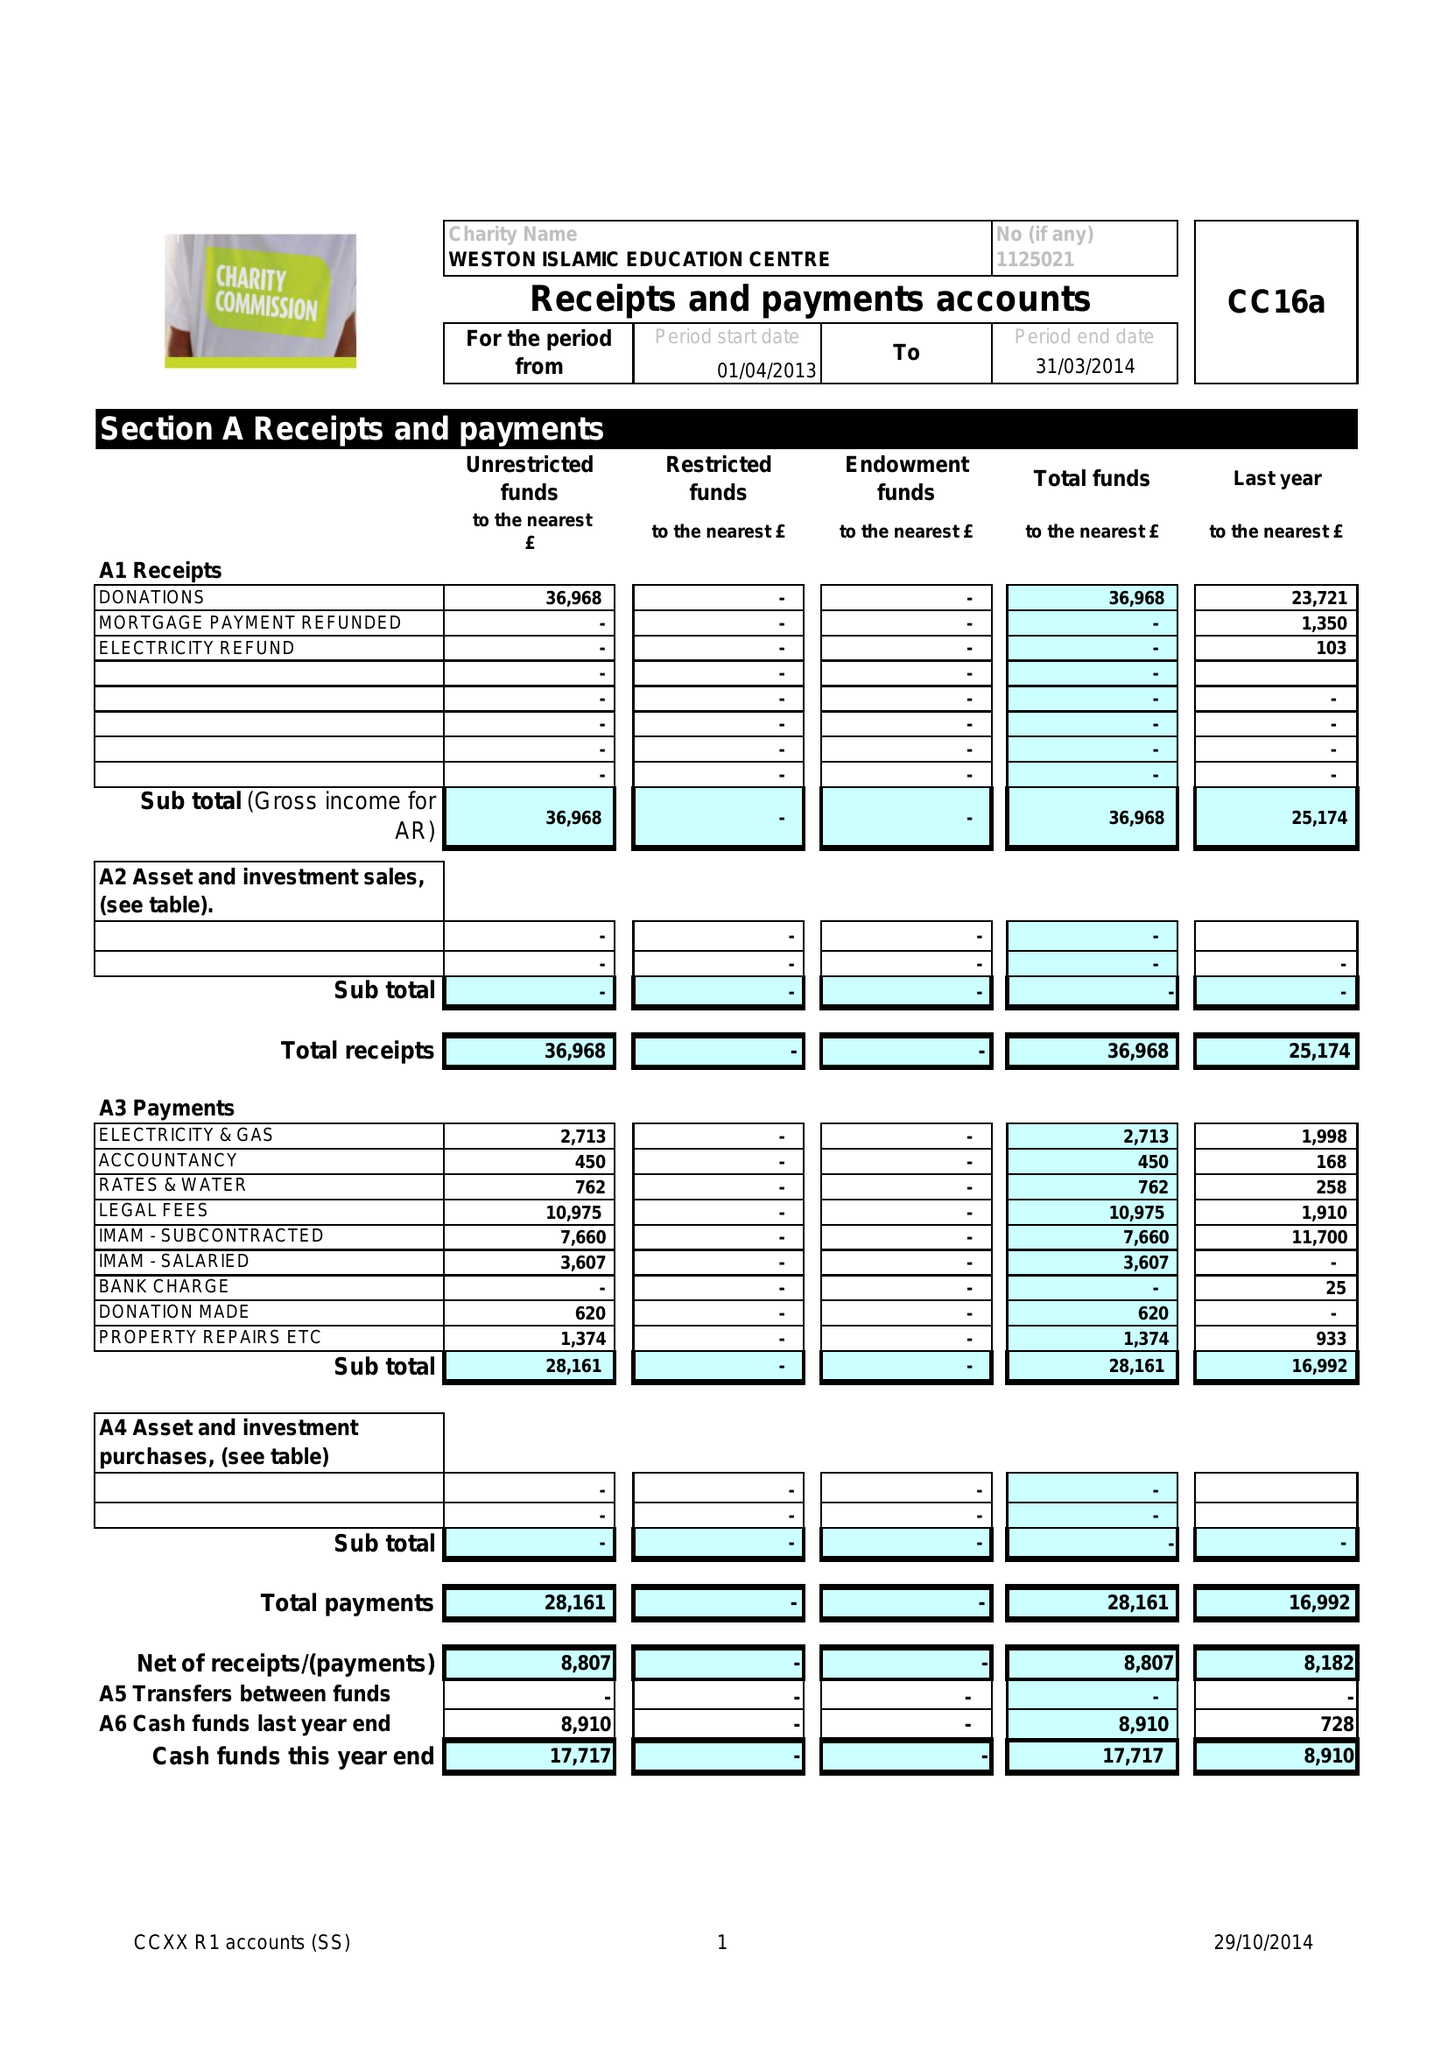What is the value for the address__postcode?
Answer the question using a single word or phrase. BS23 1RU 